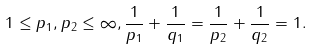Convert formula to latex. <formula><loc_0><loc_0><loc_500><loc_500>1 \leq p _ { 1 } , p _ { 2 } \leq \infty , \frac { 1 } { p _ { 1 } } + \frac { 1 } { q _ { 1 } } = \frac { 1 } { p _ { 2 } } + \frac { 1 } { q _ { 2 } } = 1 .</formula> 